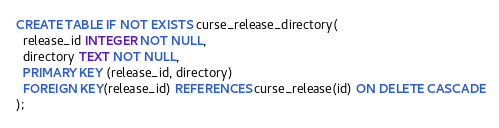<code> <loc_0><loc_0><loc_500><loc_500><_SQL_>CREATE TABLE IF NOT EXISTS curse_release_directory(
  release_id INTEGER NOT NULL,
  directory TEXT NOT NULL,
  PRIMARY KEY (release_id, directory)
  FOREIGN KEY(release_id) REFERENCES curse_release(id) ON DELETE CASCADE
);
</code> 